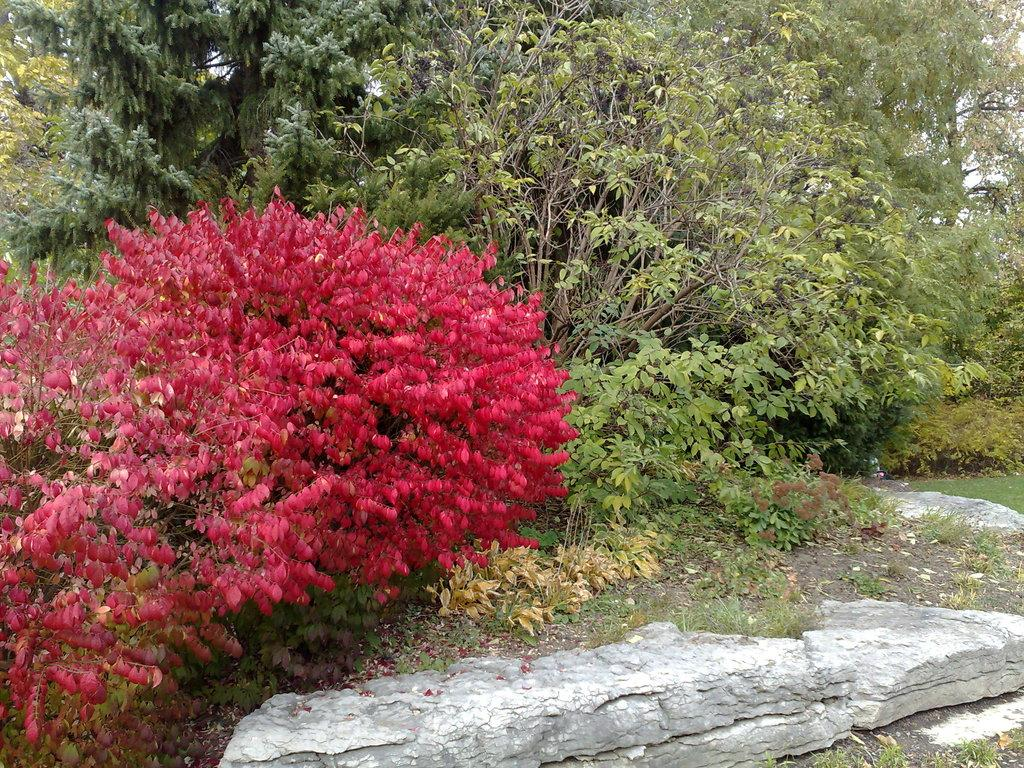What type of vegetation is present in the image? There are plants and trees in the image. Where is the grass located in the image? The grass is on the right side of the image. Can you describe any other features visible at the bottom of the image? There is a rock visible at the bottom of the image. How many planes can be seen flying over the town in the image? There are no planes or town present in the image; it features plants, trees, grass, and a rock. What type of stem is visible on the plants in the image? There is no stem visible on the plants in the image; only the leaves and branches are present. 